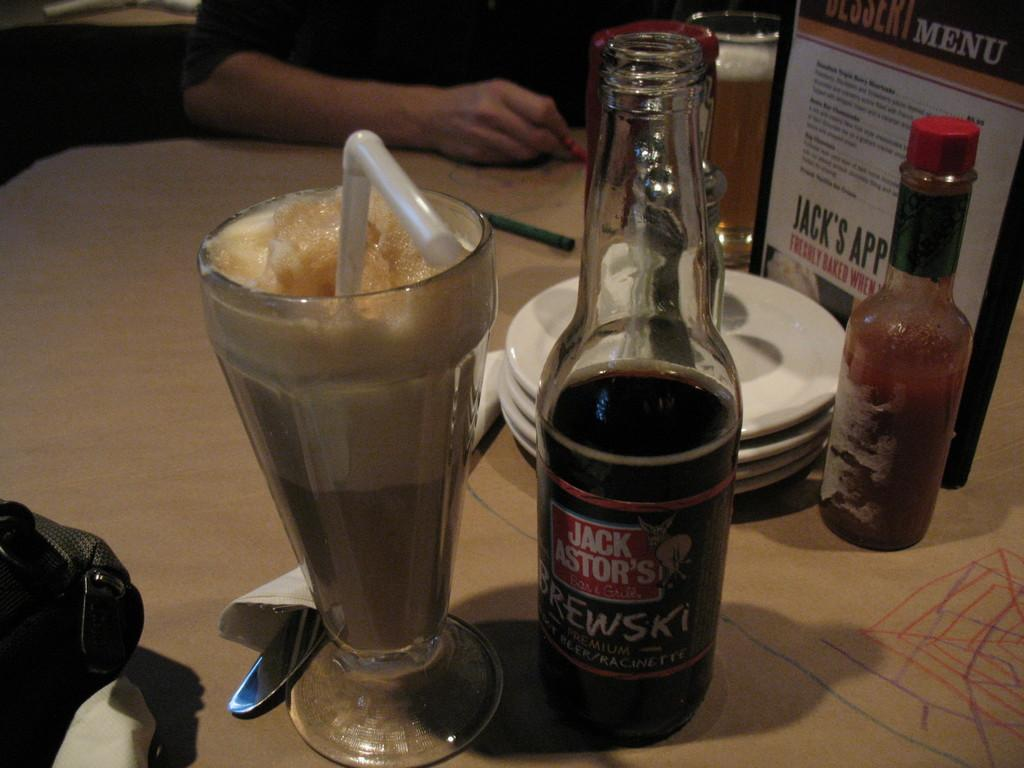<image>
Relay a brief, clear account of the picture shown. A bottled drink from the brand Jack Astor's. 